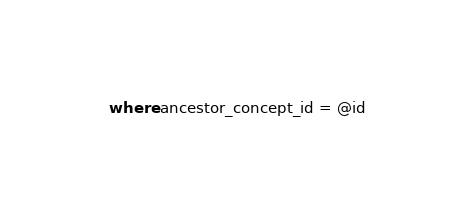<code> <loc_0><loc_0><loc_500><loc_500><_SQL_>where ancestor_concept_id = @id
</code> 